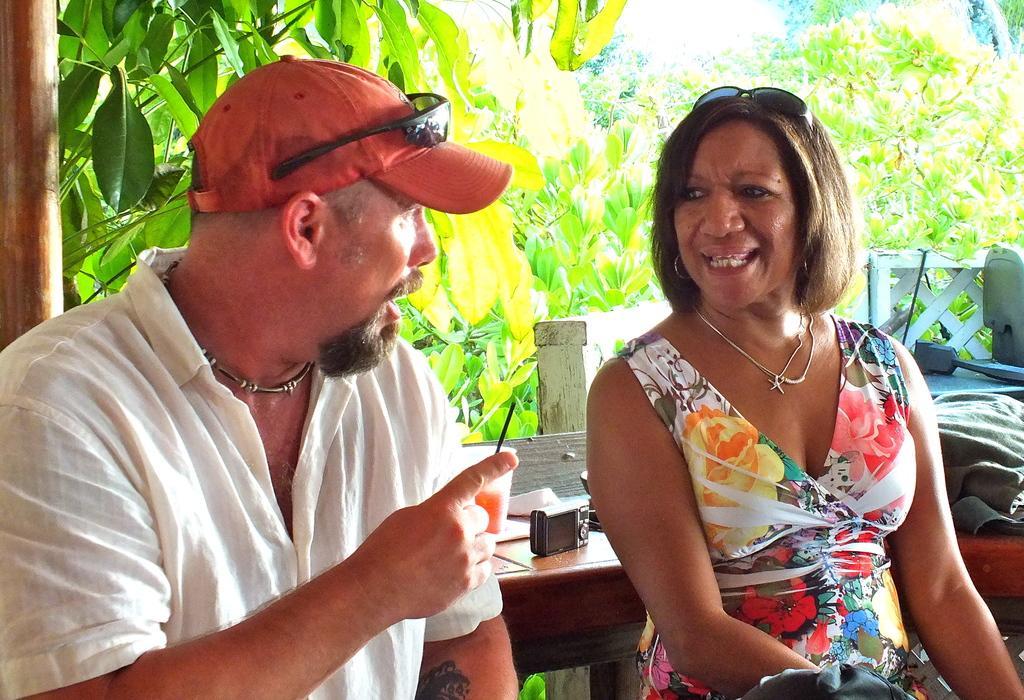Can you describe this image briefly? In this image I can see two persons in the front. I can see both of them are wearing necklaces and on their heads I can see two black shades. On the left side of the image I can see one of them is wearing a red colour cap. In the background I can see a table, number of trees and on the table I can see a glass, a camera and few other stuffs. On the right side of the image I can see a cloth and a black colour thing. On the bottom right side of the image I can see a black colour thing. 